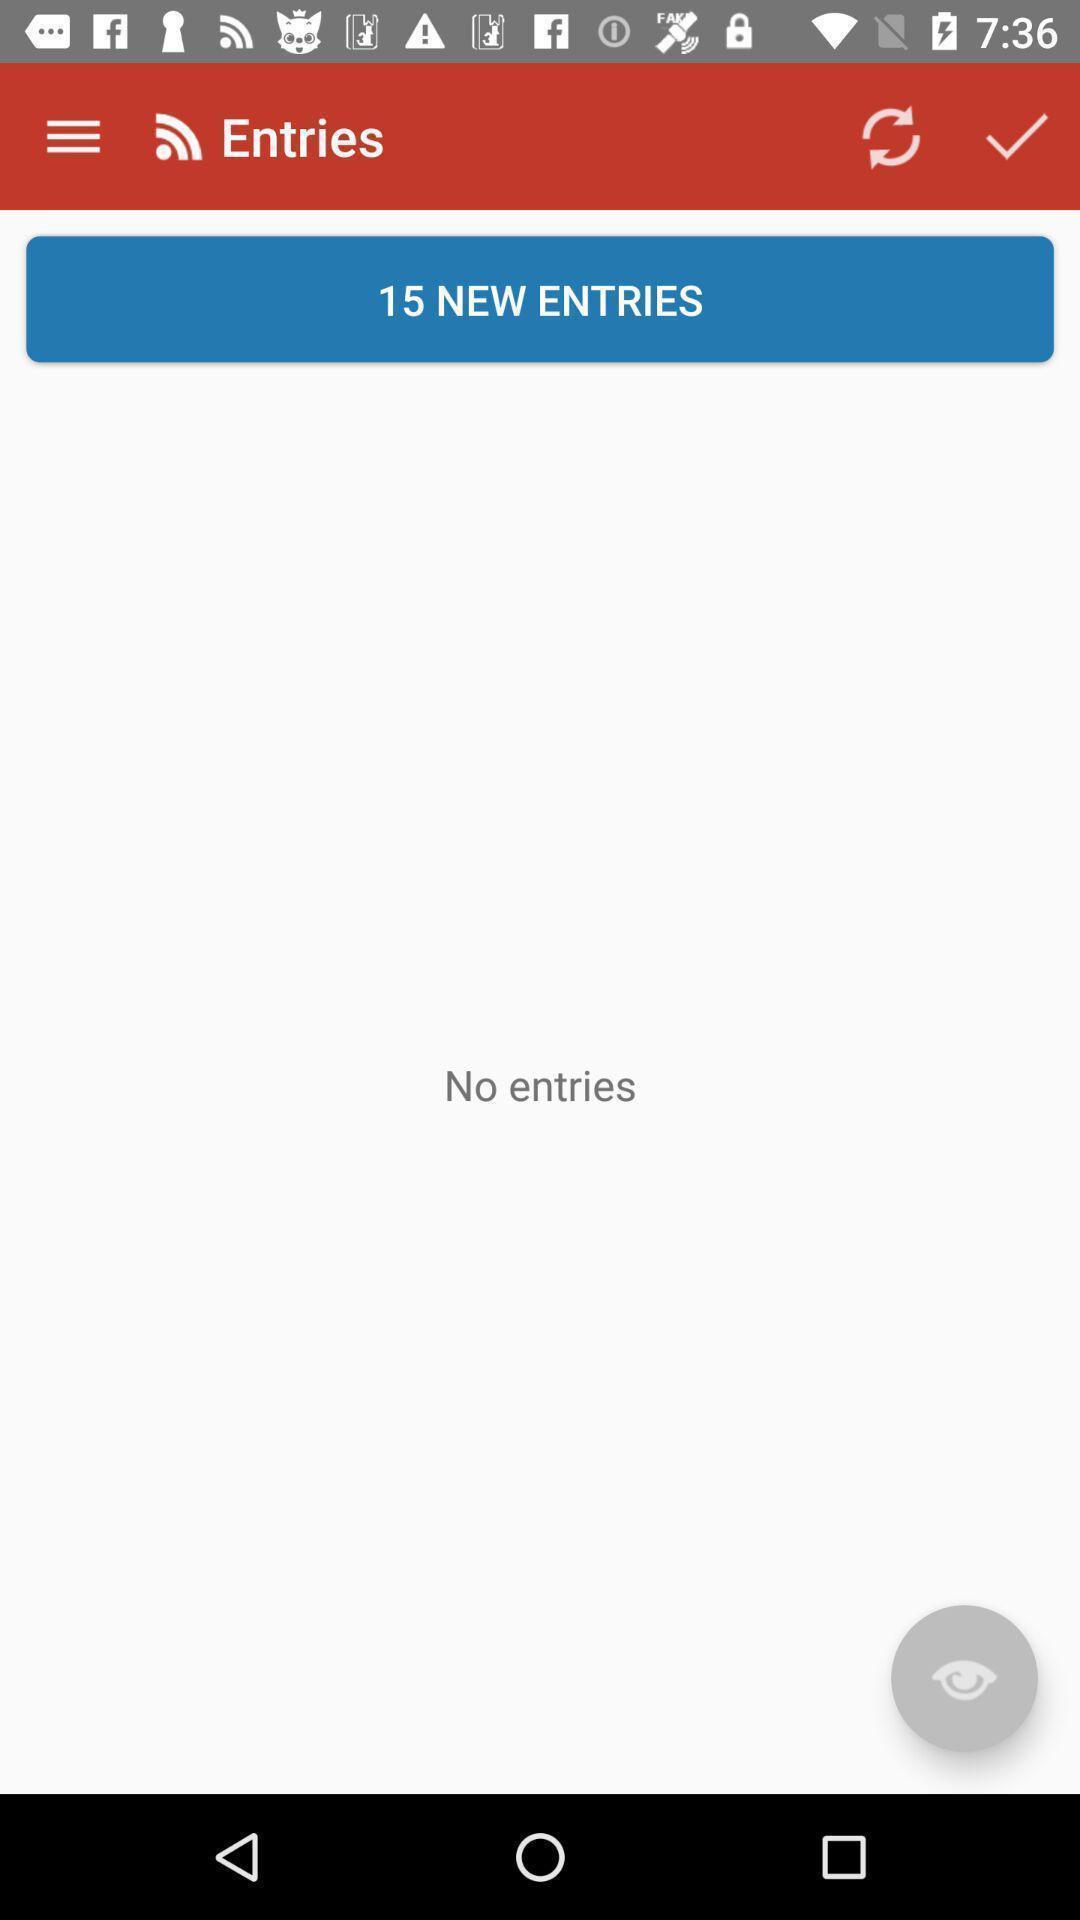What can you discern from this picture? Screen showing no entries. 